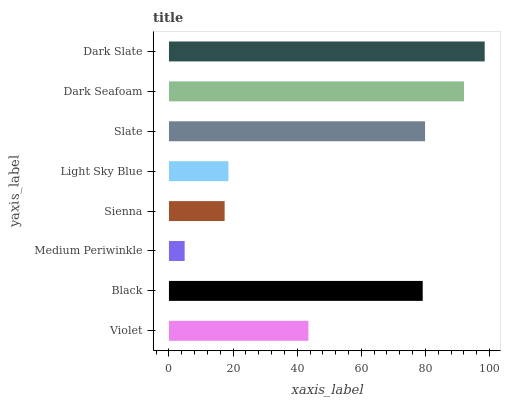Is Medium Periwinkle the minimum?
Answer yes or no. Yes. Is Dark Slate the maximum?
Answer yes or no. Yes. Is Black the minimum?
Answer yes or no. No. Is Black the maximum?
Answer yes or no. No. Is Black greater than Violet?
Answer yes or no. Yes. Is Violet less than Black?
Answer yes or no. Yes. Is Violet greater than Black?
Answer yes or no. No. Is Black less than Violet?
Answer yes or no. No. Is Black the high median?
Answer yes or no. Yes. Is Violet the low median?
Answer yes or no. Yes. Is Dark Seafoam the high median?
Answer yes or no. No. Is Light Sky Blue the low median?
Answer yes or no. No. 